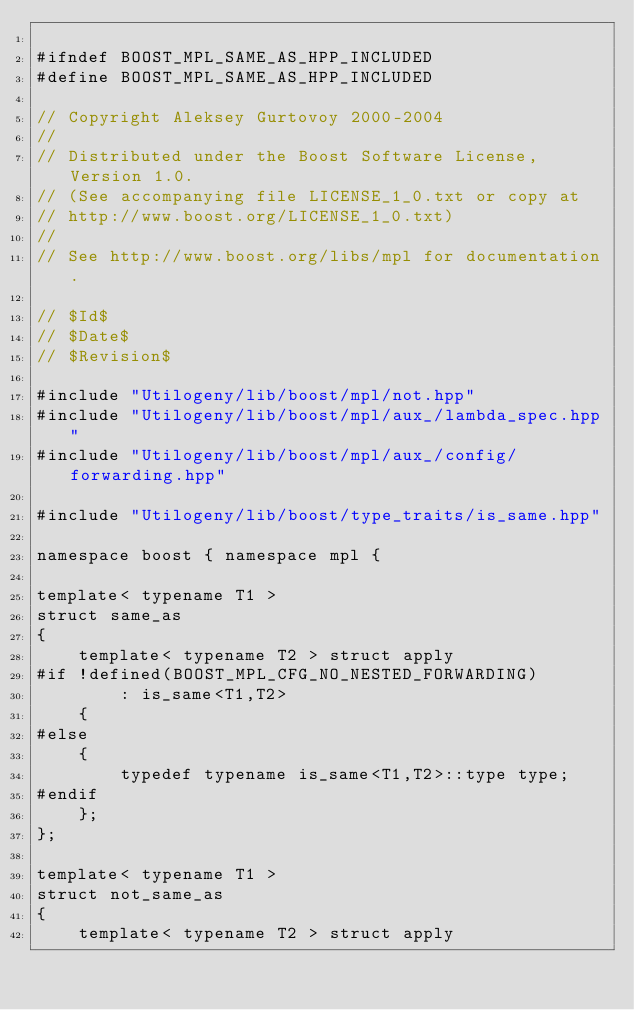<code> <loc_0><loc_0><loc_500><loc_500><_C++_>
#ifndef BOOST_MPL_SAME_AS_HPP_INCLUDED
#define BOOST_MPL_SAME_AS_HPP_INCLUDED

// Copyright Aleksey Gurtovoy 2000-2004
//
// Distributed under the Boost Software License, Version 1.0. 
// (See accompanying file LICENSE_1_0.txt or copy at 
// http://www.boost.org/LICENSE_1_0.txt)
//
// See http://www.boost.org/libs/mpl for documentation.

// $Id$
// $Date$
// $Revision$

#include "Utilogeny/lib/boost/mpl/not.hpp"
#include "Utilogeny/lib/boost/mpl/aux_/lambda_spec.hpp"
#include "Utilogeny/lib/boost/mpl/aux_/config/forwarding.hpp"

#include "Utilogeny/lib/boost/type_traits/is_same.hpp"

namespace boost { namespace mpl {

template< typename T1 >
struct same_as
{
    template< typename T2 > struct apply
#if !defined(BOOST_MPL_CFG_NO_NESTED_FORWARDING)
        : is_same<T1,T2>
    {
#else
    {
        typedef typename is_same<T1,T2>::type type;
#endif
    };
};

template< typename T1 >
struct not_same_as
{
    template< typename T2 > struct apply</code> 